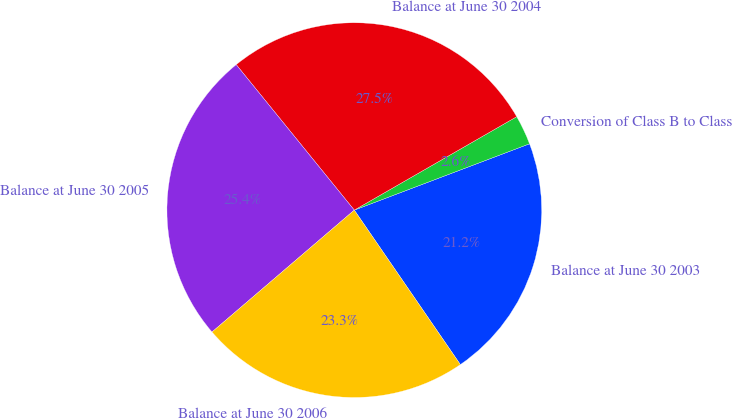Convert chart. <chart><loc_0><loc_0><loc_500><loc_500><pie_chart><fcel>Balance at June 30 2003<fcel>Conversion of Class B to Class<fcel>Balance at June 30 2004<fcel>Balance at June 30 2005<fcel>Balance at June 30 2006<nl><fcel>21.18%<fcel>2.55%<fcel>27.54%<fcel>25.42%<fcel>23.3%<nl></chart> 